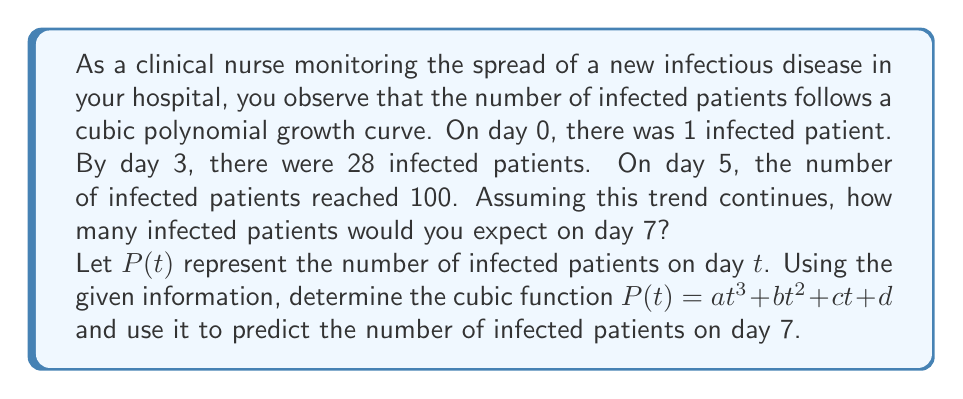Teach me how to tackle this problem. To solve this problem, we need to follow these steps:

1) We know that $P(t) = at^3 + bt^2 + ct + d$ is our cubic function.

2) We can use the given information to create a system of equations:

   $P(0) = d = 1$  (On day 0, there was 1 infected patient)
   $P(3) = 27a + 9b + 3c + 1 = 28$  (On day 3, there were 28 infected patients)
   $P(5) = 125a + 25b + 5c + 1 = 100$  (On day 5, there were 100 infected patients)

3) From the first equation, we know that $d = 1$. Let's substitute this into the other equations:

   $27a + 9b + 3c = 27$
   $125a + 25b + 5c = 99$

4) To solve this system, let's use elimination. Multiply the first equation by 5 and subtract it from the second equation:

   $135a + 45b + 15c = 135$
   $125a + 25b + 5c = 99$
   ----------------------
   $10a + 20b + 10c = 36$

5) Divide this equation by 10:

   $a + 2b + c = 3.6$

6) Now we have three unknowns and only two equations. We need one more condition to solve this system uniquely. Let's assume that $b = 0$ for simplicity (this is a common assumption when we don't have enough information).

7) With $b = 0$, our equations become:

   $27a + 3c = 27$
   $a + c = 3.6$

8) Solving this system:
   $c = 3.6 - a$
   $27a + 3(3.6 - a) = 27$
   $27a + 10.8 - 3a = 27$
   $24a = 16.2$
   $a = 0.675$

   Then, $c = 3.6 - 0.675 = 2.925$

9) Therefore, our function is:

   $P(t) = 0.675t^3 + 2.925t + 1$

10) To find the number of infected patients on day 7, we calculate $P(7)$:

    $P(7) = 0.675(7^3) + 2.925(7) + 1$
          $= 0.675(343) + 20.475 + 1$
          $= 231.525 + 20.475 + 1$
          $= 253$
Answer: On day 7, you would expect approximately 253 infected patients. 